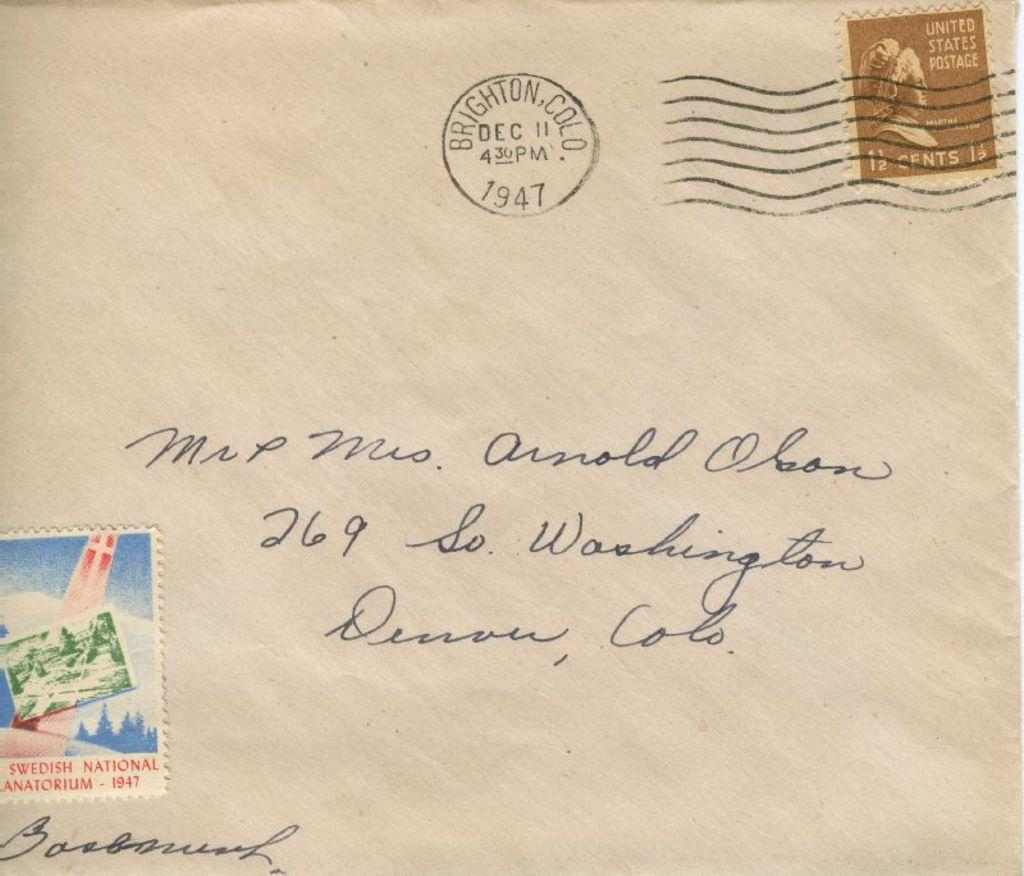<image>
Create a compact narrative representing the image presented. Letter that has a stamp saying United States Postage. 